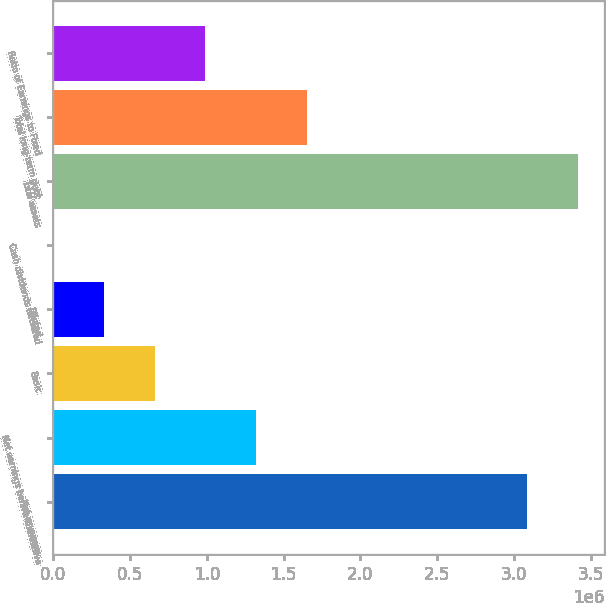<chart> <loc_0><loc_0><loc_500><loc_500><bar_chart><fcel>Net revenues<fcel>Net earnings before cumulative<fcel>Basic<fcel>Diluted<fcel>Cash dividends declared<fcel>Total assets<fcel>Total long-term debt<fcel>Ratio of Earnings to Fixed<nl><fcel>3.08763e+06<fcel>1.32046e+06<fcel>660229<fcel>330115<fcel>0.36<fcel>3.41774e+06<fcel>1.65057e+06<fcel>990343<nl></chart> 